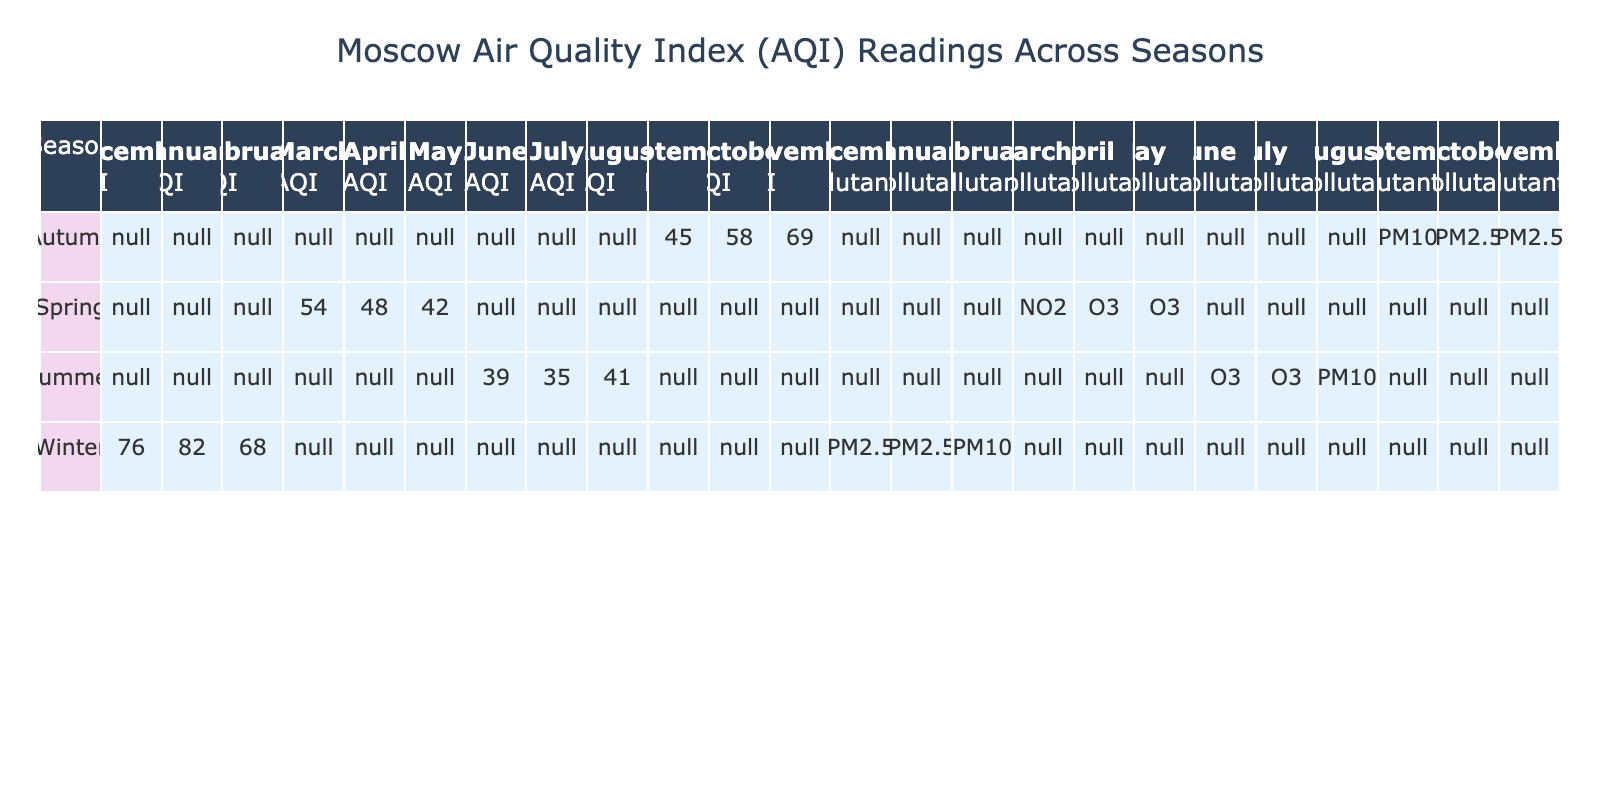What is the AQI reading for the month of January? The AQI reading for January can be directly found in the table under the Winter season and January column. It shows a value of 82.
Answer: 82 What is the lowest AQI recorded in Spring? Looking at the Spring season in the table, the lowest AQI is found in May with a reading of 42.
Answer: 42 How does the AQI in July compare to the AQI in November? The AQI in July is 35 and in November it is 69. To compare, November's AQI (69) is higher than July's AQI (35).
Answer: November's AQI is higher What is the average AQI for Winter? The AQI readings for Winter months (December, January, February) are 76, 82, and 68. Summing these values gives 76 + 82 + 68 = 226. There are 3 months, so the average AQI is 226/3 = 75.33.
Answer: 75.33 Which pollutant had the highest reading in the Autumn season? The AQI readings for Autumn are listed under September (45, PM10), October (58, PM2.5), and November (69, PM2.5). The highest reading is November's AQI of 69 for PM2.5.
Answer: PM2.5 Is there an AQI reading in any season that is greater than 80? Looking across all seasons, the only AQI reading greater than 80 is January with a value of 82. Thus, the statement is true.
Answer: Yes What is the difference in AQI between the highest and lowest reading in Summer? In Summer, the AQI readings are June (39) and July (35) and August (41). The highest in Summer is 41 (August) and the lowest is 35 (July). The difference is 41 - 35 = 6.
Answer: 6 How many seasons have an AQI reading below 50? Checking the table, only Spring has AQI readings below 50 (in April: 48, and May: 42). There are 2 months in Spring with AQI below 50, but no entire season is below 50. So the answer is one season (Spring).
Answer: 1 What pollutant is most often associated with the highest AQI readings in the table? The highest readings in the table (January: 82, November: 69) are linked to PM2.5. Therefore, it can be determined that PM2.5 is most often associated with the highest AQI.
Answer: PM2.5 Which month has the best air quality according to AQI readings? Evaluating all months, May has the lowest AQI reading of 42. Therefore, May is the month with the best air quality according to the AQI.
Answer: May 